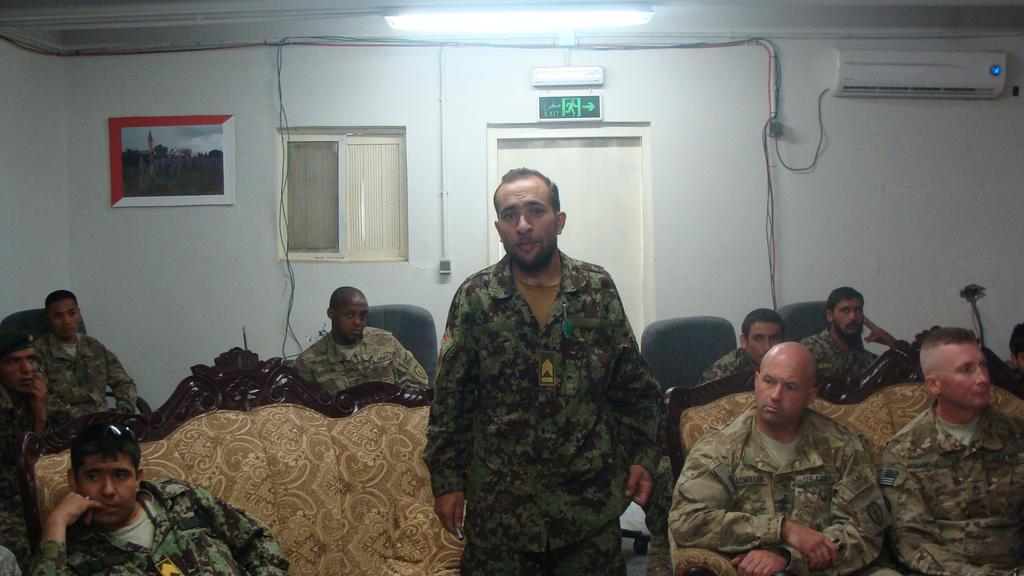What type of people are present in the image? There are army people in the image. What are the army people doing in the image? The army people are sitting in chairs and on a couch. Are there any standing individuals in the image? Yes, one person is standing in the image. What is the standing person doing? The standing person is talking. What brand of toothpaste is visible on the table in the image? There is no toothpaste present in the image. What type of glove is being worn by the army people in the image? There is no glove visible in the image. 